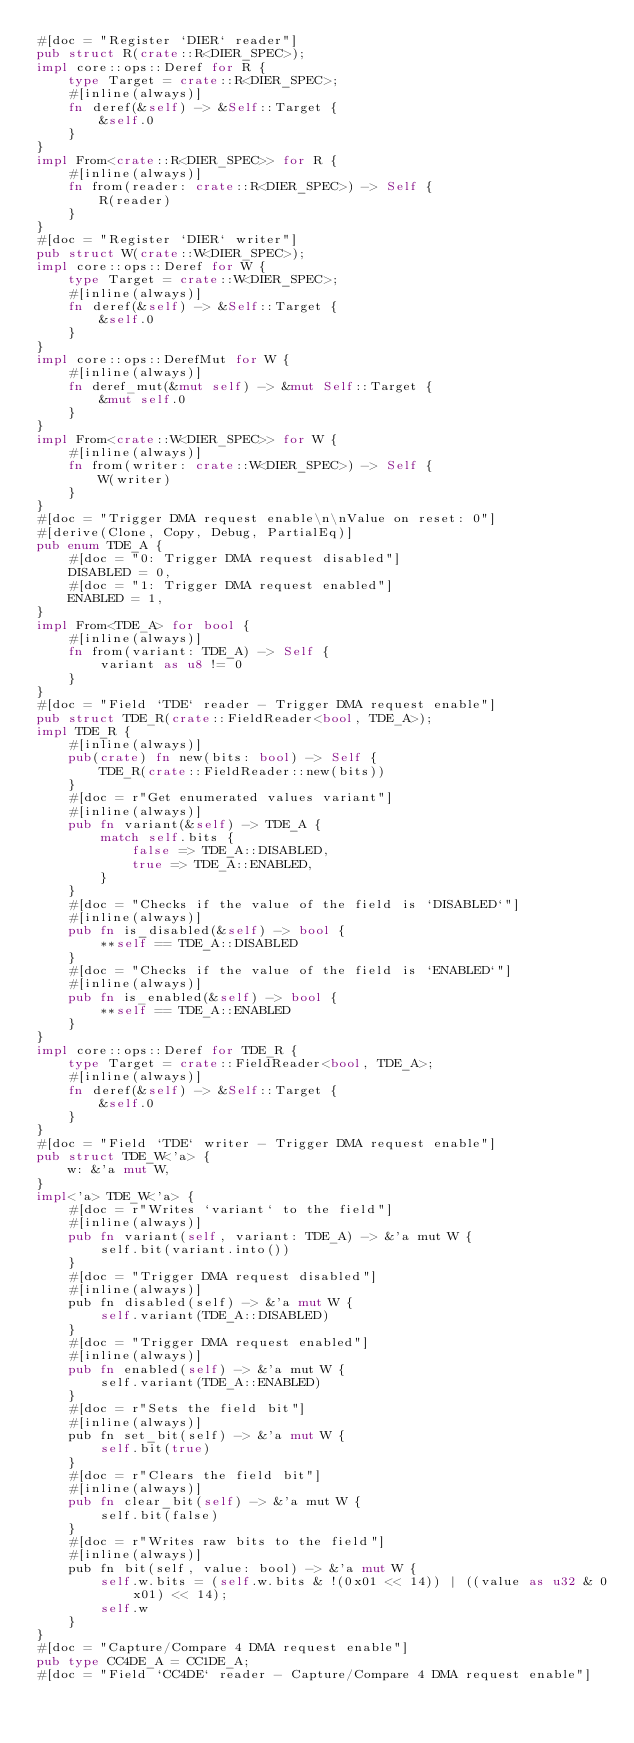Convert code to text. <code><loc_0><loc_0><loc_500><loc_500><_Rust_>#[doc = "Register `DIER` reader"]
pub struct R(crate::R<DIER_SPEC>);
impl core::ops::Deref for R {
    type Target = crate::R<DIER_SPEC>;
    #[inline(always)]
    fn deref(&self) -> &Self::Target {
        &self.0
    }
}
impl From<crate::R<DIER_SPEC>> for R {
    #[inline(always)]
    fn from(reader: crate::R<DIER_SPEC>) -> Self {
        R(reader)
    }
}
#[doc = "Register `DIER` writer"]
pub struct W(crate::W<DIER_SPEC>);
impl core::ops::Deref for W {
    type Target = crate::W<DIER_SPEC>;
    #[inline(always)]
    fn deref(&self) -> &Self::Target {
        &self.0
    }
}
impl core::ops::DerefMut for W {
    #[inline(always)]
    fn deref_mut(&mut self) -> &mut Self::Target {
        &mut self.0
    }
}
impl From<crate::W<DIER_SPEC>> for W {
    #[inline(always)]
    fn from(writer: crate::W<DIER_SPEC>) -> Self {
        W(writer)
    }
}
#[doc = "Trigger DMA request enable\n\nValue on reset: 0"]
#[derive(Clone, Copy, Debug, PartialEq)]
pub enum TDE_A {
    #[doc = "0: Trigger DMA request disabled"]
    DISABLED = 0,
    #[doc = "1: Trigger DMA request enabled"]
    ENABLED = 1,
}
impl From<TDE_A> for bool {
    #[inline(always)]
    fn from(variant: TDE_A) -> Self {
        variant as u8 != 0
    }
}
#[doc = "Field `TDE` reader - Trigger DMA request enable"]
pub struct TDE_R(crate::FieldReader<bool, TDE_A>);
impl TDE_R {
    #[inline(always)]
    pub(crate) fn new(bits: bool) -> Self {
        TDE_R(crate::FieldReader::new(bits))
    }
    #[doc = r"Get enumerated values variant"]
    #[inline(always)]
    pub fn variant(&self) -> TDE_A {
        match self.bits {
            false => TDE_A::DISABLED,
            true => TDE_A::ENABLED,
        }
    }
    #[doc = "Checks if the value of the field is `DISABLED`"]
    #[inline(always)]
    pub fn is_disabled(&self) -> bool {
        **self == TDE_A::DISABLED
    }
    #[doc = "Checks if the value of the field is `ENABLED`"]
    #[inline(always)]
    pub fn is_enabled(&self) -> bool {
        **self == TDE_A::ENABLED
    }
}
impl core::ops::Deref for TDE_R {
    type Target = crate::FieldReader<bool, TDE_A>;
    #[inline(always)]
    fn deref(&self) -> &Self::Target {
        &self.0
    }
}
#[doc = "Field `TDE` writer - Trigger DMA request enable"]
pub struct TDE_W<'a> {
    w: &'a mut W,
}
impl<'a> TDE_W<'a> {
    #[doc = r"Writes `variant` to the field"]
    #[inline(always)]
    pub fn variant(self, variant: TDE_A) -> &'a mut W {
        self.bit(variant.into())
    }
    #[doc = "Trigger DMA request disabled"]
    #[inline(always)]
    pub fn disabled(self) -> &'a mut W {
        self.variant(TDE_A::DISABLED)
    }
    #[doc = "Trigger DMA request enabled"]
    #[inline(always)]
    pub fn enabled(self) -> &'a mut W {
        self.variant(TDE_A::ENABLED)
    }
    #[doc = r"Sets the field bit"]
    #[inline(always)]
    pub fn set_bit(self) -> &'a mut W {
        self.bit(true)
    }
    #[doc = r"Clears the field bit"]
    #[inline(always)]
    pub fn clear_bit(self) -> &'a mut W {
        self.bit(false)
    }
    #[doc = r"Writes raw bits to the field"]
    #[inline(always)]
    pub fn bit(self, value: bool) -> &'a mut W {
        self.w.bits = (self.w.bits & !(0x01 << 14)) | ((value as u32 & 0x01) << 14);
        self.w
    }
}
#[doc = "Capture/Compare 4 DMA request enable"]
pub type CC4DE_A = CC1DE_A;
#[doc = "Field `CC4DE` reader - Capture/Compare 4 DMA request enable"]</code> 